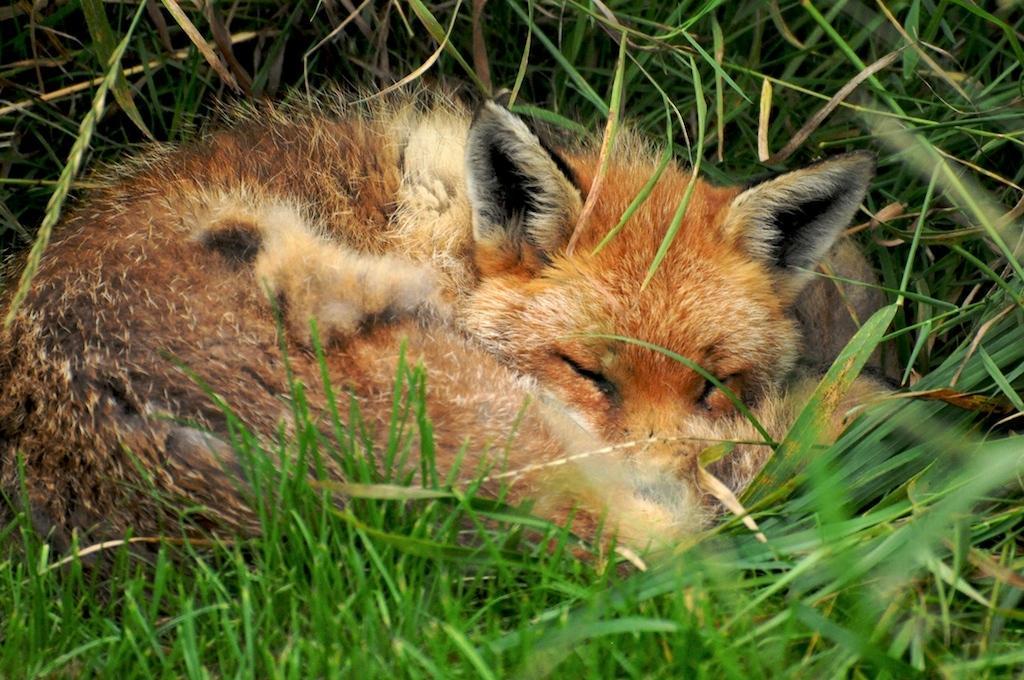Can you describe this image briefly? In this image there is a swift fox sleeping in the grass, behind the fox there is grass. 